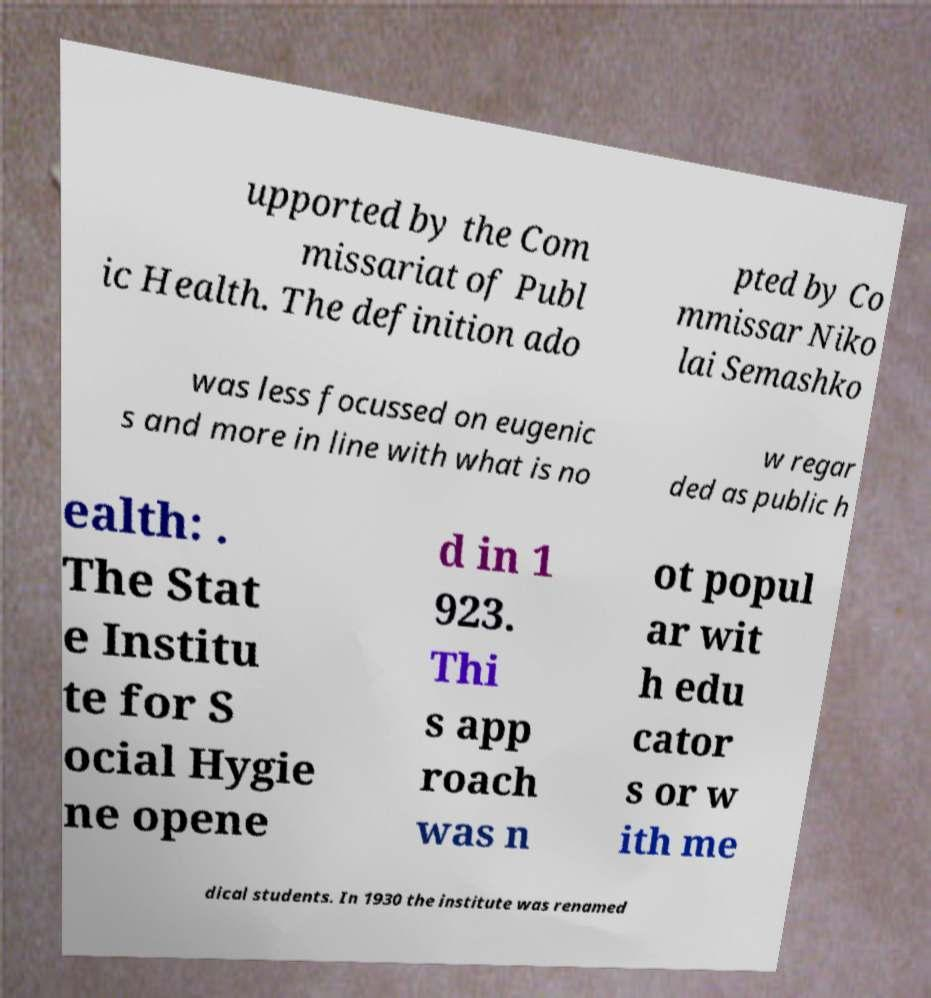Please identify and transcribe the text found in this image. upported by the Com missariat of Publ ic Health. The definition ado pted by Co mmissar Niko lai Semashko was less focussed on eugenic s and more in line with what is no w regar ded as public h ealth: . The Stat e Institu te for S ocial Hygie ne opene d in 1 923. Thi s app roach was n ot popul ar wit h edu cator s or w ith me dical students. In 1930 the institute was renamed 